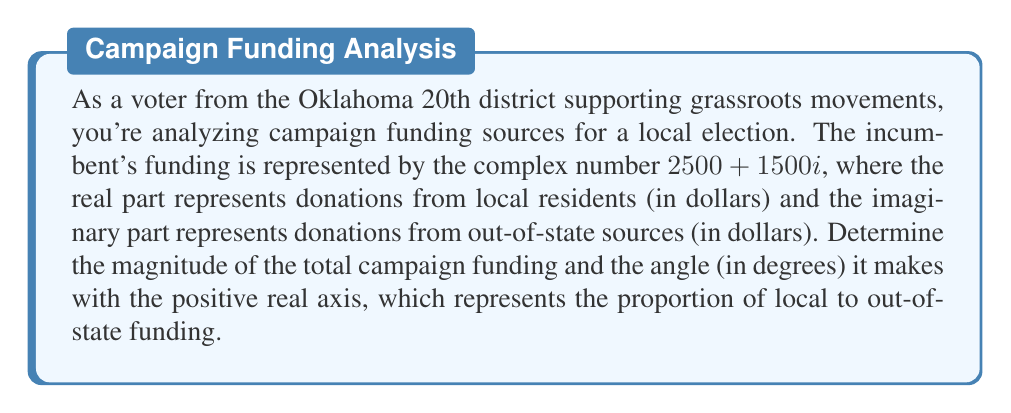Provide a solution to this math problem. To solve this problem, we need to convert the complex number into its polar form, which will give us the magnitude and angle.

1. Calculate the magnitude:
   The magnitude $r$ is given by the formula: $r = \sqrt{a^2 + b^2}$, where $a$ is the real part and $b$ is the imaginary part.
   
   $r = \sqrt{2500^2 + 1500^2} = \sqrt{6,250,000 + 2,250,000} = \sqrt{8,500,000} = 2915.48$

2. Calculate the angle:
   The angle $\theta$ is given by the formula: $\theta = \tan^{-1}(\frac{b}{a})$, where $a$ is the real part and $b$ is the imaginary part.
   
   $\theta = \tan^{-1}(\frac{1500}{2500}) = \tan^{-1}(0.6) = 30.96^\circ$

The magnitude represents the total amount of campaign funding, while the angle represents the proportion of out-of-state to local funding. An angle of 0° would mean all local funding, while 90° would mean all out-of-state funding.

[asy]
import geometry;

size(200);
real r = 2915.48;
real theta = 30.96 * pi / 180;

draw((-500,0)--(3500,0), arrow=Arrow(TeXHead));
draw((0,-500)--(0,2500), arrow=Arrow(TeXHead));

draw((0,0)--(r*cos(theta), r*sin(theta)), arrow=Arrow(TeXHead), p=blue+1);
draw(arc((0,0), 500, 0, theta), L=Label("30.96°", position=MidPoint));

label("Local funding (real axis)", (3500,0), E);
label("Out-of-state funding (imaginary axis)", (0,2500), N);
label("$2915.48", (r*cos(theta)/2, r*sin(theta)/2), NE);

dot((2500,1500), p=red);
label("(2500, 1500i)", (2500,1500), NE);
[/asy]
Answer: The magnitude of the total campaign funding is $2915.48, and the angle it makes with the positive real axis is $30.96^\circ$. 